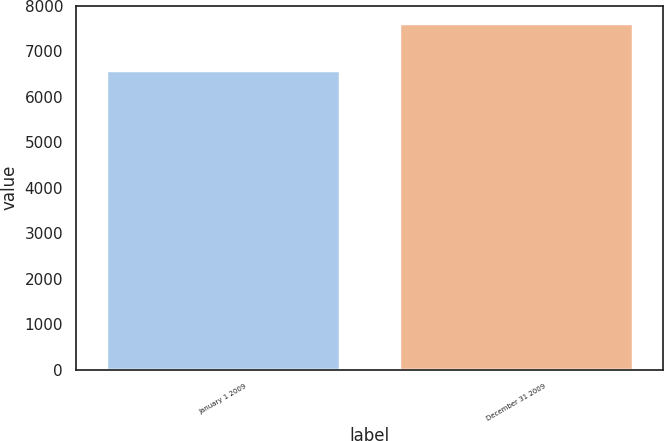Convert chart. <chart><loc_0><loc_0><loc_500><loc_500><bar_chart><fcel>January 1 2009<fcel>December 31 2009<nl><fcel>6596.2<fcel>7620.8<nl></chart> 